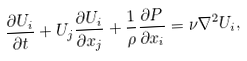<formula> <loc_0><loc_0><loc_500><loc_500>\frac { \partial U _ { i } } { \partial t } + U _ { j } \frac { \partial U _ { i } } { \partial x _ { j } } + \frac { 1 } { \rho } \frac { \partial P } { \partial x _ { i } } = \nu \nabla ^ { 2 } U _ { i } ,</formula> 